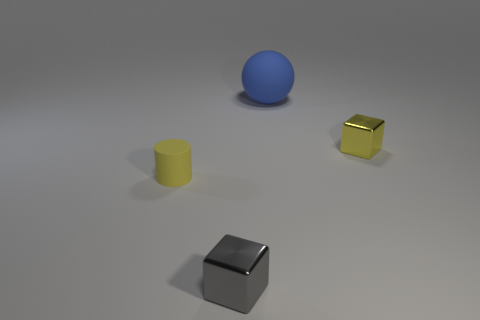How many objects are there and can you describe their positions relative to each other? There are three objects in the image. The largest object, a blue sphere, is placed further back, left of center. In the middle, there is a yellow cylinder, and to the right of it sits a smaller, gold-colored cube. In front of these is a silver cube centered close to the bottom of the frame.  Can you describe the lighting and shadows of the scene? The lighting appears to be coming from above, casting soft, diffuse shadows to the right of each object. The shadows suggest a single primary light source, and the evenness of the illumination provides a calm and balanced atmosphere. 